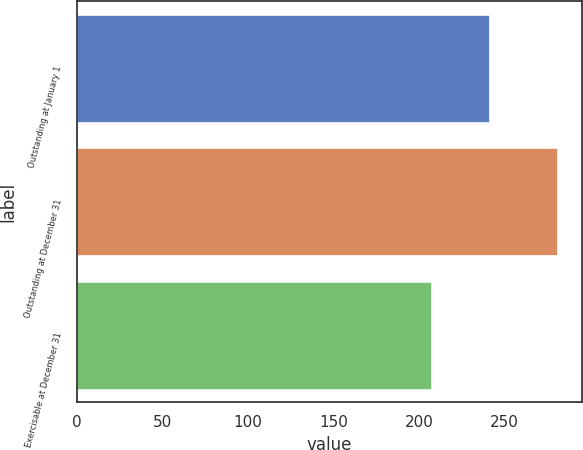Convert chart to OTSL. <chart><loc_0><loc_0><loc_500><loc_500><bar_chart><fcel>Outstanding at January 1<fcel>Outstanding at December 31<fcel>Exercisable at December 31<nl><fcel>241<fcel>281<fcel>207<nl></chart> 